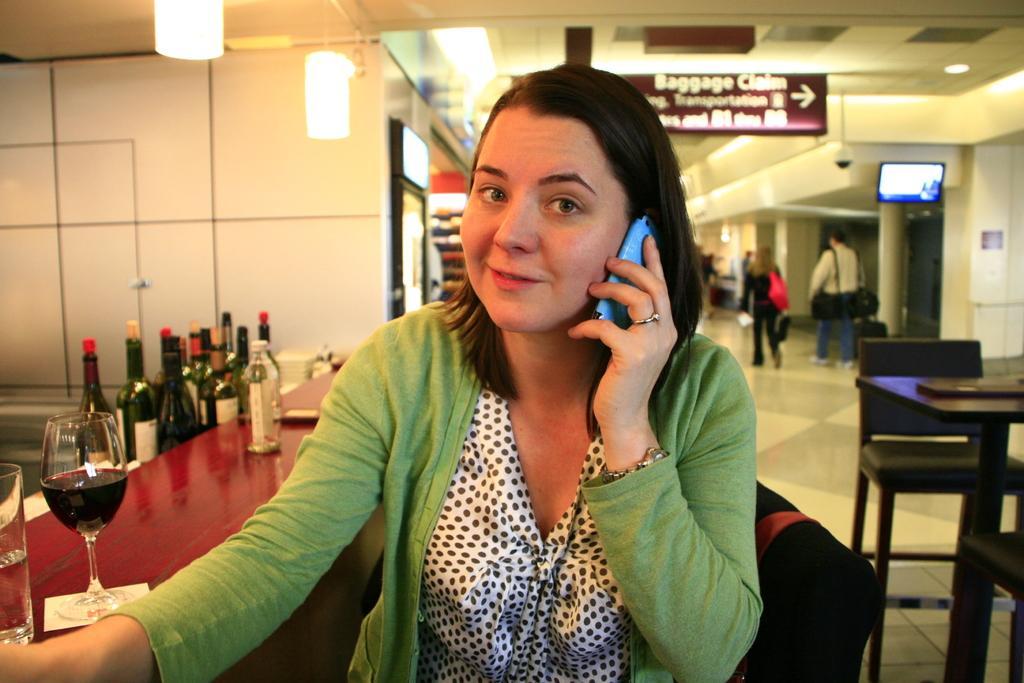Can you describe this image briefly? There is a woman speaking and the phone behind her there is a table with some alcohol bottles on it and there is a glass with the wine at the back there are few people walking on the way and there is aTV and a sign board on the wall. 